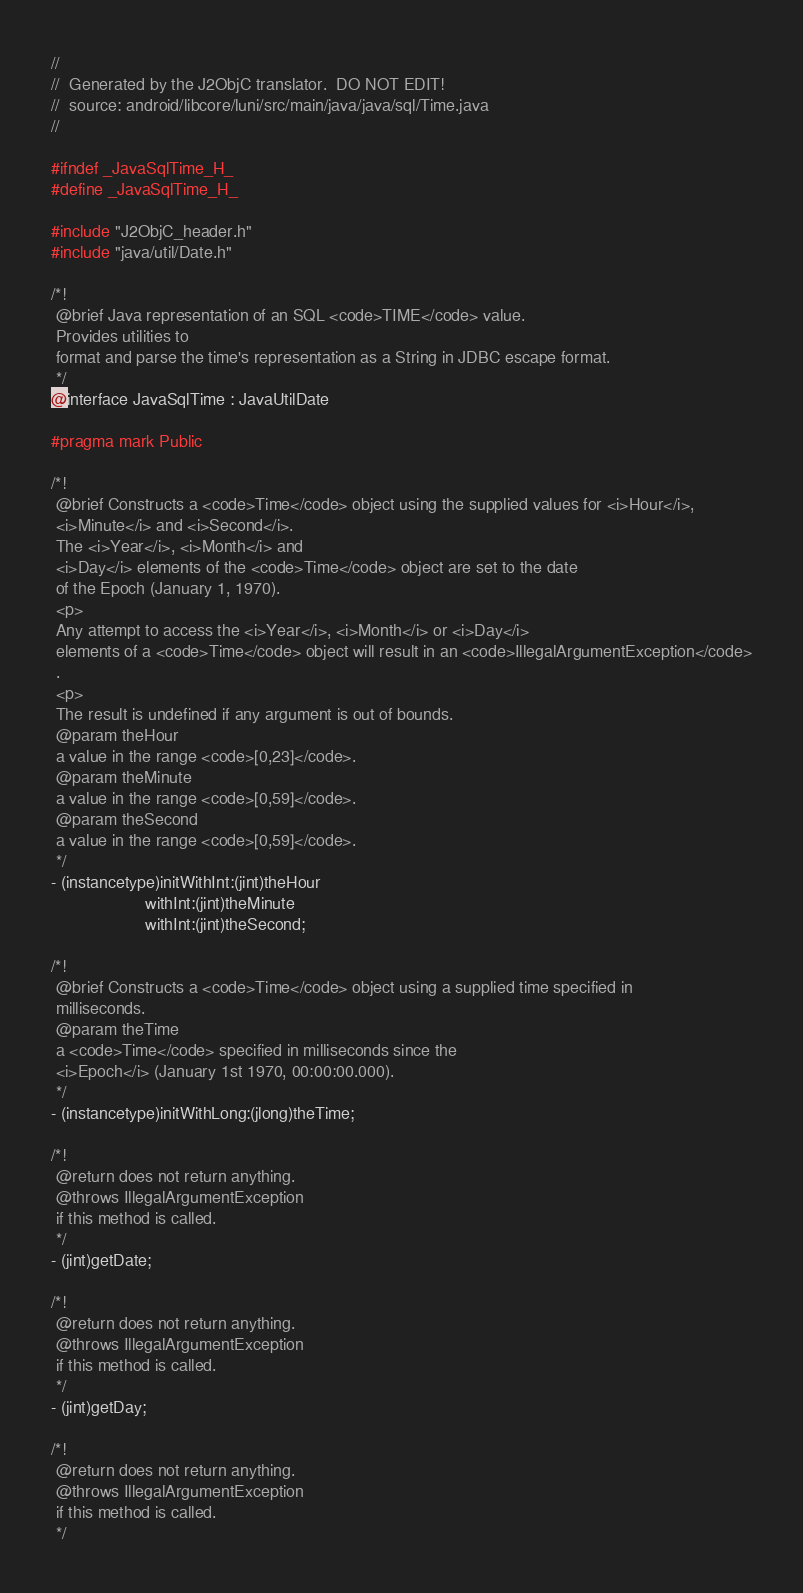<code> <loc_0><loc_0><loc_500><loc_500><_C_>//
//  Generated by the J2ObjC translator.  DO NOT EDIT!
//  source: android/libcore/luni/src/main/java/java/sql/Time.java
//

#ifndef _JavaSqlTime_H_
#define _JavaSqlTime_H_

#include "J2ObjC_header.h"
#include "java/util/Date.h"

/*!
 @brief Java representation of an SQL <code>TIME</code> value.
 Provides utilities to
 format and parse the time's representation as a String in JDBC escape format.
 */
@interface JavaSqlTime : JavaUtilDate

#pragma mark Public

/*!
 @brief Constructs a <code>Time</code> object using the supplied values for <i>Hour</i>,
 <i>Minute</i> and <i>Second</i>.
 The <i>Year</i>, <i>Month</i> and
 <i>Day</i> elements of the <code>Time</code> object are set to the date
 of the Epoch (January 1, 1970).
 <p>
 Any attempt to access the <i>Year</i>, <i>Month</i> or <i>Day</i>
 elements of a <code>Time</code> object will result in an <code>IllegalArgumentException</code>
 .
 <p>
 The result is undefined if any argument is out of bounds.
 @param theHour
 a value in the range <code>[0,23]</code>.
 @param theMinute
 a value in the range <code>[0,59]</code>.
 @param theSecond
 a value in the range <code>[0,59]</code>.
 */
- (instancetype)initWithInt:(jint)theHour
                    withInt:(jint)theMinute
                    withInt:(jint)theSecond;

/*!
 @brief Constructs a <code>Time</code> object using a supplied time specified in
 milliseconds.
 @param theTime
 a <code>Time</code> specified in milliseconds since the
 <i>Epoch</i> (January 1st 1970, 00:00:00.000).
 */
- (instancetype)initWithLong:(jlong)theTime;

/*!
 @return does not return anything.
 @throws IllegalArgumentException
 if this method is called.
 */
- (jint)getDate;

/*!
 @return does not return anything.
 @throws IllegalArgumentException
 if this method is called.
 */
- (jint)getDay;

/*!
 @return does not return anything.
 @throws IllegalArgumentException
 if this method is called.
 */</code> 